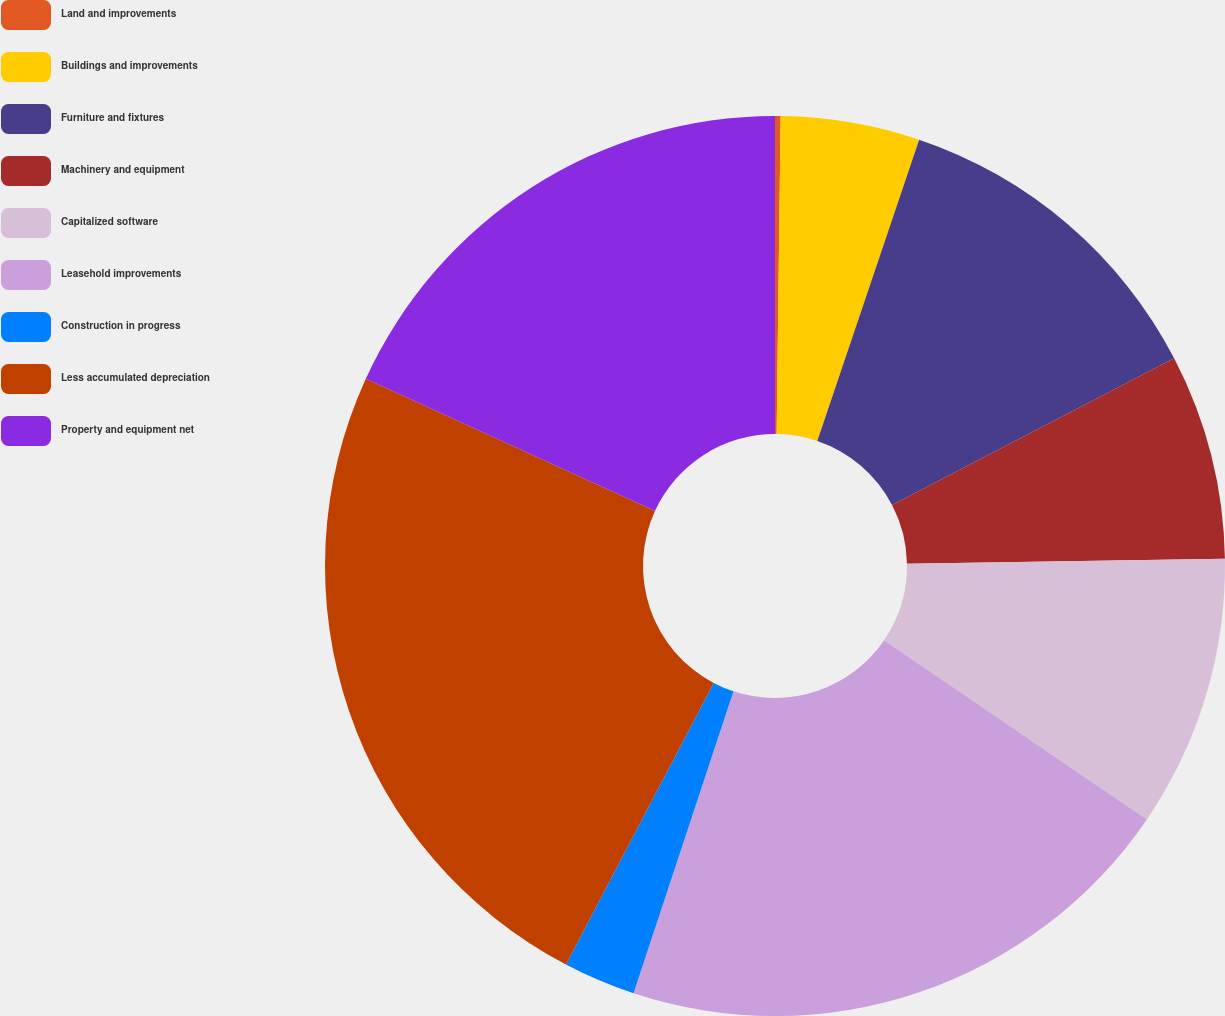Convert chart to OTSL. <chart><loc_0><loc_0><loc_500><loc_500><pie_chart><fcel>Land and improvements<fcel>Buildings and improvements<fcel>Furniture and fixtures<fcel>Machinery and equipment<fcel>Capitalized software<fcel>Leasehold improvements<fcel>Construction in progress<fcel>Less accumulated depreciation<fcel>Property and equipment net<nl><fcel>0.2%<fcel>4.99%<fcel>12.17%<fcel>7.38%<fcel>9.78%<fcel>20.57%<fcel>2.6%<fcel>24.14%<fcel>18.17%<nl></chart> 